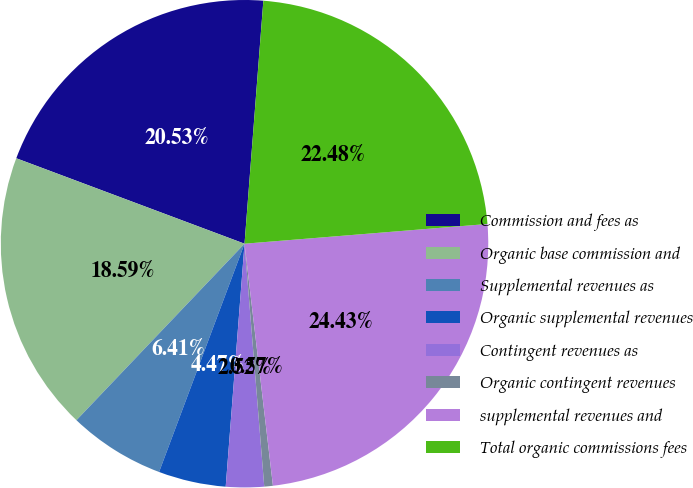Convert chart to OTSL. <chart><loc_0><loc_0><loc_500><loc_500><pie_chart><fcel>Commission and fees as<fcel>Organic base commission and<fcel>Supplemental revenues as<fcel>Organic supplemental revenues<fcel>Contingent revenues as<fcel>Organic contingent revenues<fcel>supplemental revenues and<fcel>Total organic commissions fees<nl><fcel>20.53%<fcel>18.59%<fcel>6.41%<fcel>4.47%<fcel>2.52%<fcel>0.57%<fcel>24.43%<fcel>22.48%<nl></chart> 